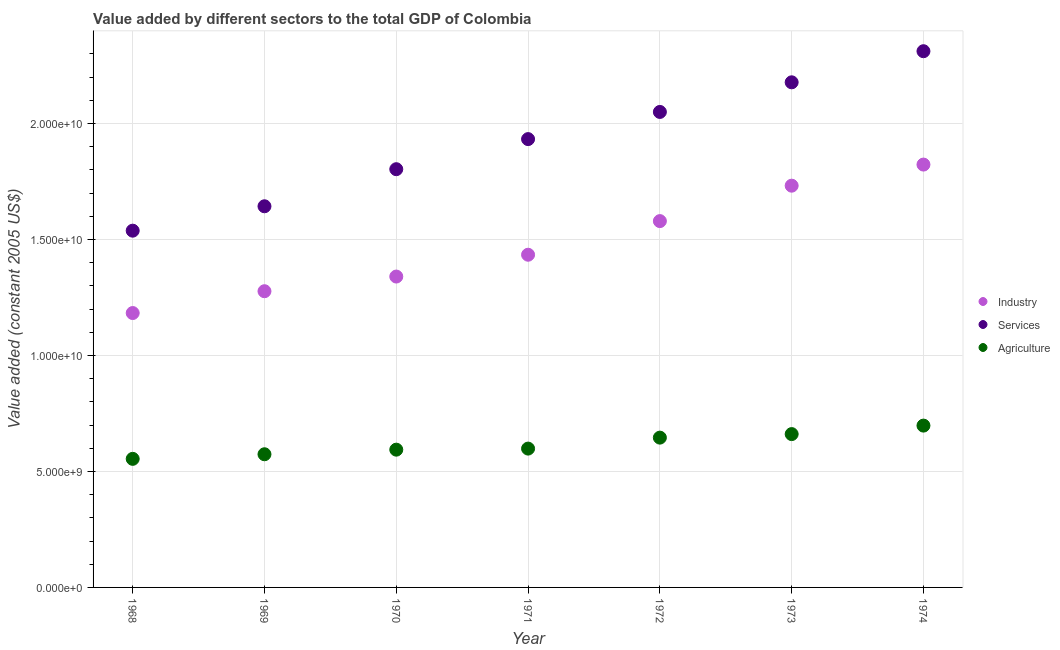How many different coloured dotlines are there?
Keep it short and to the point. 3. What is the value added by services in 1972?
Provide a short and direct response. 2.05e+1. Across all years, what is the maximum value added by industrial sector?
Make the answer very short. 1.82e+1. Across all years, what is the minimum value added by agricultural sector?
Offer a very short reply. 5.54e+09. In which year was the value added by agricultural sector maximum?
Offer a terse response. 1974. In which year was the value added by industrial sector minimum?
Make the answer very short. 1968. What is the total value added by services in the graph?
Provide a succinct answer. 1.35e+11. What is the difference between the value added by services in 1972 and that in 1974?
Ensure brevity in your answer.  -2.62e+09. What is the difference between the value added by services in 1972 and the value added by agricultural sector in 1970?
Provide a short and direct response. 1.46e+1. What is the average value added by services per year?
Your answer should be compact. 1.92e+1. In the year 1968, what is the difference between the value added by industrial sector and value added by agricultural sector?
Ensure brevity in your answer.  6.28e+09. What is the ratio of the value added by industrial sector in 1969 to that in 1971?
Make the answer very short. 0.89. What is the difference between the highest and the second highest value added by services?
Ensure brevity in your answer.  1.34e+09. What is the difference between the highest and the lowest value added by industrial sector?
Provide a succinct answer. 6.40e+09. Is the sum of the value added by agricultural sector in 1972 and 1974 greater than the maximum value added by industrial sector across all years?
Offer a terse response. No. Is it the case that in every year, the sum of the value added by industrial sector and value added by services is greater than the value added by agricultural sector?
Offer a terse response. Yes. Is the value added by services strictly less than the value added by industrial sector over the years?
Offer a terse response. No. What is the difference between two consecutive major ticks on the Y-axis?
Offer a terse response. 5.00e+09. Does the graph contain grids?
Ensure brevity in your answer.  Yes. How are the legend labels stacked?
Offer a terse response. Vertical. What is the title of the graph?
Your answer should be compact. Value added by different sectors to the total GDP of Colombia. What is the label or title of the X-axis?
Offer a terse response. Year. What is the label or title of the Y-axis?
Offer a very short reply. Value added (constant 2005 US$). What is the Value added (constant 2005 US$) in Industry in 1968?
Your answer should be very brief. 1.18e+1. What is the Value added (constant 2005 US$) of Services in 1968?
Your answer should be compact. 1.54e+1. What is the Value added (constant 2005 US$) of Agriculture in 1968?
Keep it short and to the point. 5.54e+09. What is the Value added (constant 2005 US$) in Industry in 1969?
Keep it short and to the point. 1.28e+1. What is the Value added (constant 2005 US$) in Services in 1969?
Give a very brief answer. 1.64e+1. What is the Value added (constant 2005 US$) of Agriculture in 1969?
Make the answer very short. 5.74e+09. What is the Value added (constant 2005 US$) in Industry in 1970?
Your response must be concise. 1.34e+1. What is the Value added (constant 2005 US$) of Services in 1970?
Give a very brief answer. 1.80e+1. What is the Value added (constant 2005 US$) of Agriculture in 1970?
Offer a very short reply. 5.94e+09. What is the Value added (constant 2005 US$) in Industry in 1971?
Make the answer very short. 1.43e+1. What is the Value added (constant 2005 US$) of Services in 1971?
Your answer should be compact. 1.93e+1. What is the Value added (constant 2005 US$) of Agriculture in 1971?
Provide a short and direct response. 5.98e+09. What is the Value added (constant 2005 US$) in Industry in 1972?
Offer a very short reply. 1.58e+1. What is the Value added (constant 2005 US$) in Services in 1972?
Ensure brevity in your answer.  2.05e+1. What is the Value added (constant 2005 US$) of Agriculture in 1972?
Provide a succinct answer. 6.46e+09. What is the Value added (constant 2005 US$) of Industry in 1973?
Provide a short and direct response. 1.73e+1. What is the Value added (constant 2005 US$) of Services in 1973?
Your answer should be compact. 2.18e+1. What is the Value added (constant 2005 US$) in Agriculture in 1973?
Offer a very short reply. 6.61e+09. What is the Value added (constant 2005 US$) in Industry in 1974?
Keep it short and to the point. 1.82e+1. What is the Value added (constant 2005 US$) in Services in 1974?
Your response must be concise. 2.31e+1. What is the Value added (constant 2005 US$) in Agriculture in 1974?
Offer a very short reply. 6.97e+09. Across all years, what is the maximum Value added (constant 2005 US$) in Industry?
Provide a short and direct response. 1.82e+1. Across all years, what is the maximum Value added (constant 2005 US$) of Services?
Your response must be concise. 2.31e+1. Across all years, what is the maximum Value added (constant 2005 US$) of Agriculture?
Give a very brief answer. 6.97e+09. Across all years, what is the minimum Value added (constant 2005 US$) of Industry?
Your response must be concise. 1.18e+1. Across all years, what is the minimum Value added (constant 2005 US$) in Services?
Make the answer very short. 1.54e+1. Across all years, what is the minimum Value added (constant 2005 US$) in Agriculture?
Provide a succinct answer. 5.54e+09. What is the total Value added (constant 2005 US$) in Industry in the graph?
Give a very brief answer. 1.04e+11. What is the total Value added (constant 2005 US$) of Services in the graph?
Make the answer very short. 1.35e+11. What is the total Value added (constant 2005 US$) of Agriculture in the graph?
Give a very brief answer. 4.32e+1. What is the difference between the Value added (constant 2005 US$) in Industry in 1968 and that in 1969?
Keep it short and to the point. -9.41e+08. What is the difference between the Value added (constant 2005 US$) in Services in 1968 and that in 1969?
Keep it short and to the point. -1.05e+09. What is the difference between the Value added (constant 2005 US$) of Agriculture in 1968 and that in 1969?
Your response must be concise. -1.98e+08. What is the difference between the Value added (constant 2005 US$) of Industry in 1968 and that in 1970?
Keep it short and to the point. -1.57e+09. What is the difference between the Value added (constant 2005 US$) in Services in 1968 and that in 1970?
Your answer should be compact. -2.65e+09. What is the difference between the Value added (constant 2005 US$) of Agriculture in 1968 and that in 1970?
Make the answer very short. -3.96e+08. What is the difference between the Value added (constant 2005 US$) of Industry in 1968 and that in 1971?
Offer a terse response. -2.51e+09. What is the difference between the Value added (constant 2005 US$) of Services in 1968 and that in 1971?
Your response must be concise. -3.95e+09. What is the difference between the Value added (constant 2005 US$) in Agriculture in 1968 and that in 1971?
Make the answer very short. -4.42e+08. What is the difference between the Value added (constant 2005 US$) in Industry in 1968 and that in 1972?
Keep it short and to the point. -3.96e+09. What is the difference between the Value added (constant 2005 US$) in Services in 1968 and that in 1972?
Make the answer very short. -5.12e+09. What is the difference between the Value added (constant 2005 US$) of Agriculture in 1968 and that in 1972?
Offer a terse response. -9.15e+08. What is the difference between the Value added (constant 2005 US$) of Industry in 1968 and that in 1973?
Your response must be concise. -5.49e+09. What is the difference between the Value added (constant 2005 US$) of Services in 1968 and that in 1973?
Give a very brief answer. -6.40e+09. What is the difference between the Value added (constant 2005 US$) in Agriculture in 1968 and that in 1973?
Provide a short and direct response. -1.07e+09. What is the difference between the Value added (constant 2005 US$) in Industry in 1968 and that in 1974?
Provide a short and direct response. -6.40e+09. What is the difference between the Value added (constant 2005 US$) in Services in 1968 and that in 1974?
Provide a succinct answer. -7.74e+09. What is the difference between the Value added (constant 2005 US$) in Agriculture in 1968 and that in 1974?
Make the answer very short. -1.43e+09. What is the difference between the Value added (constant 2005 US$) of Industry in 1969 and that in 1970?
Your answer should be very brief. -6.32e+08. What is the difference between the Value added (constant 2005 US$) in Services in 1969 and that in 1970?
Provide a succinct answer. -1.60e+09. What is the difference between the Value added (constant 2005 US$) of Agriculture in 1969 and that in 1970?
Offer a terse response. -1.98e+08. What is the difference between the Value added (constant 2005 US$) in Industry in 1969 and that in 1971?
Keep it short and to the point. -1.57e+09. What is the difference between the Value added (constant 2005 US$) in Services in 1969 and that in 1971?
Your answer should be compact. -2.90e+09. What is the difference between the Value added (constant 2005 US$) in Agriculture in 1969 and that in 1971?
Your answer should be compact. -2.44e+08. What is the difference between the Value added (constant 2005 US$) in Industry in 1969 and that in 1972?
Make the answer very short. -3.02e+09. What is the difference between the Value added (constant 2005 US$) in Services in 1969 and that in 1972?
Provide a succinct answer. -4.07e+09. What is the difference between the Value added (constant 2005 US$) in Agriculture in 1969 and that in 1972?
Offer a terse response. -7.17e+08. What is the difference between the Value added (constant 2005 US$) of Industry in 1969 and that in 1973?
Your answer should be very brief. -4.55e+09. What is the difference between the Value added (constant 2005 US$) in Services in 1969 and that in 1973?
Ensure brevity in your answer.  -5.34e+09. What is the difference between the Value added (constant 2005 US$) in Agriculture in 1969 and that in 1973?
Ensure brevity in your answer.  -8.69e+08. What is the difference between the Value added (constant 2005 US$) in Industry in 1969 and that in 1974?
Your answer should be compact. -5.46e+09. What is the difference between the Value added (constant 2005 US$) of Services in 1969 and that in 1974?
Your answer should be very brief. -6.68e+09. What is the difference between the Value added (constant 2005 US$) in Agriculture in 1969 and that in 1974?
Your answer should be compact. -1.23e+09. What is the difference between the Value added (constant 2005 US$) in Industry in 1970 and that in 1971?
Keep it short and to the point. -9.41e+08. What is the difference between the Value added (constant 2005 US$) in Services in 1970 and that in 1971?
Provide a succinct answer. -1.30e+09. What is the difference between the Value added (constant 2005 US$) in Agriculture in 1970 and that in 1971?
Offer a very short reply. -4.57e+07. What is the difference between the Value added (constant 2005 US$) of Industry in 1970 and that in 1972?
Give a very brief answer. -2.39e+09. What is the difference between the Value added (constant 2005 US$) in Services in 1970 and that in 1972?
Your response must be concise. -2.47e+09. What is the difference between the Value added (constant 2005 US$) in Agriculture in 1970 and that in 1972?
Ensure brevity in your answer.  -5.18e+08. What is the difference between the Value added (constant 2005 US$) in Industry in 1970 and that in 1973?
Provide a succinct answer. -3.92e+09. What is the difference between the Value added (constant 2005 US$) of Services in 1970 and that in 1973?
Your response must be concise. -3.75e+09. What is the difference between the Value added (constant 2005 US$) of Agriculture in 1970 and that in 1973?
Provide a short and direct response. -6.71e+08. What is the difference between the Value added (constant 2005 US$) of Industry in 1970 and that in 1974?
Make the answer very short. -4.83e+09. What is the difference between the Value added (constant 2005 US$) of Services in 1970 and that in 1974?
Keep it short and to the point. -5.09e+09. What is the difference between the Value added (constant 2005 US$) of Agriculture in 1970 and that in 1974?
Offer a very short reply. -1.04e+09. What is the difference between the Value added (constant 2005 US$) in Industry in 1971 and that in 1972?
Keep it short and to the point. -1.45e+09. What is the difference between the Value added (constant 2005 US$) in Services in 1971 and that in 1972?
Your response must be concise. -1.17e+09. What is the difference between the Value added (constant 2005 US$) in Agriculture in 1971 and that in 1972?
Your answer should be compact. -4.73e+08. What is the difference between the Value added (constant 2005 US$) in Industry in 1971 and that in 1973?
Offer a terse response. -2.98e+09. What is the difference between the Value added (constant 2005 US$) of Services in 1971 and that in 1973?
Your response must be concise. -2.45e+09. What is the difference between the Value added (constant 2005 US$) in Agriculture in 1971 and that in 1973?
Give a very brief answer. -6.25e+08. What is the difference between the Value added (constant 2005 US$) of Industry in 1971 and that in 1974?
Offer a terse response. -3.89e+09. What is the difference between the Value added (constant 2005 US$) of Services in 1971 and that in 1974?
Give a very brief answer. -3.79e+09. What is the difference between the Value added (constant 2005 US$) in Agriculture in 1971 and that in 1974?
Your answer should be compact. -9.91e+08. What is the difference between the Value added (constant 2005 US$) in Industry in 1972 and that in 1973?
Make the answer very short. -1.53e+09. What is the difference between the Value added (constant 2005 US$) in Services in 1972 and that in 1973?
Your response must be concise. -1.28e+09. What is the difference between the Value added (constant 2005 US$) in Agriculture in 1972 and that in 1973?
Provide a succinct answer. -1.52e+08. What is the difference between the Value added (constant 2005 US$) of Industry in 1972 and that in 1974?
Give a very brief answer. -2.44e+09. What is the difference between the Value added (constant 2005 US$) in Services in 1972 and that in 1974?
Give a very brief answer. -2.62e+09. What is the difference between the Value added (constant 2005 US$) of Agriculture in 1972 and that in 1974?
Ensure brevity in your answer.  -5.18e+08. What is the difference between the Value added (constant 2005 US$) of Industry in 1973 and that in 1974?
Ensure brevity in your answer.  -9.10e+08. What is the difference between the Value added (constant 2005 US$) of Services in 1973 and that in 1974?
Offer a very short reply. -1.34e+09. What is the difference between the Value added (constant 2005 US$) in Agriculture in 1973 and that in 1974?
Offer a very short reply. -3.66e+08. What is the difference between the Value added (constant 2005 US$) in Industry in 1968 and the Value added (constant 2005 US$) in Services in 1969?
Offer a terse response. -4.60e+09. What is the difference between the Value added (constant 2005 US$) in Industry in 1968 and the Value added (constant 2005 US$) in Agriculture in 1969?
Make the answer very short. 6.09e+09. What is the difference between the Value added (constant 2005 US$) of Services in 1968 and the Value added (constant 2005 US$) of Agriculture in 1969?
Ensure brevity in your answer.  9.64e+09. What is the difference between the Value added (constant 2005 US$) in Industry in 1968 and the Value added (constant 2005 US$) in Services in 1970?
Your response must be concise. -6.20e+09. What is the difference between the Value added (constant 2005 US$) of Industry in 1968 and the Value added (constant 2005 US$) of Agriculture in 1970?
Ensure brevity in your answer.  5.89e+09. What is the difference between the Value added (constant 2005 US$) of Services in 1968 and the Value added (constant 2005 US$) of Agriculture in 1970?
Give a very brief answer. 9.44e+09. What is the difference between the Value added (constant 2005 US$) in Industry in 1968 and the Value added (constant 2005 US$) in Services in 1971?
Provide a short and direct response. -7.50e+09. What is the difference between the Value added (constant 2005 US$) in Industry in 1968 and the Value added (constant 2005 US$) in Agriculture in 1971?
Your response must be concise. 5.84e+09. What is the difference between the Value added (constant 2005 US$) in Services in 1968 and the Value added (constant 2005 US$) in Agriculture in 1971?
Offer a very short reply. 9.39e+09. What is the difference between the Value added (constant 2005 US$) of Industry in 1968 and the Value added (constant 2005 US$) of Services in 1972?
Ensure brevity in your answer.  -8.67e+09. What is the difference between the Value added (constant 2005 US$) of Industry in 1968 and the Value added (constant 2005 US$) of Agriculture in 1972?
Ensure brevity in your answer.  5.37e+09. What is the difference between the Value added (constant 2005 US$) in Services in 1968 and the Value added (constant 2005 US$) in Agriculture in 1972?
Offer a very short reply. 8.92e+09. What is the difference between the Value added (constant 2005 US$) in Industry in 1968 and the Value added (constant 2005 US$) in Services in 1973?
Your answer should be very brief. -9.95e+09. What is the difference between the Value added (constant 2005 US$) of Industry in 1968 and the Value added (constant 2005 US$) of Agriculture in 1973?
Provide a succinct answer. 5.22e+09. What is the difference between the Value added (constant 2005 US$) of Services in 1968 and the Value added (constant 2005 US$) of Agriculture in 1973?
Your answer should be very brief. 8.77e+09. What is the difference between the Value added (constant 2005 US$) in Industry in 1968 and the Value added (constant 2005 US$) in Services in 1974?
Offer a very short reply. -1.13e+1. What is the difference between the Value added (constant 2005 US$) of Industry in 1968 and the Value added (constant 2005 US$) of Agriculture in 1974?
Your answer should be very brief. 4.85e+09. What is the difference between the Value added (constant 2005 US$) of Services in 1968 and the Value added (constant 2005 US$) of Agriculture in 1974?
Your answer should be very brief. 8.40e+09. What is the difference between the Value added (constant 2005 US$) in Industry in 1969 and the Value added (constant 2005 US$) in Services in 1970?
Ensure brevity in your answer.  -5.26e+09. What is the difference between the Value added (constant 2005 US$) of Industry in 1969 and the Value added (constant 2005 US$) of Agriculture in 1970?
Your response must be concise. 6.83e+09. What is the difference between the Value added (constant 2005 US$) of Services in 1969 and the Value added (constant 2005 US$) of Agriculture in 1970?
Offer a terse response. 1.05e+1. What is the difference between the Value added (constant 2005 US$) in Industry in 1969 and the Value added (constant 2005 US$) in Services in 1971?
Your response must be concise. -6.56e+09. What is the difference between the Value added (constant 2005 US$) of Industry in 1969 and the Value added (constant 2005 US$) of Agriculture in 1971?
Provide a succinct answer. 6.78e+09. What is the difference between the Value added (constant 2005 US$) in Services in 1969 and the Value added (constant 2005 US$) in Agriculture in 1971?
Your answer should be very brief. 1.04e+1. What is the difference between the Value added (constant 2005 US$) of Industry in 1969 and the Value added (constant 2005 US$) of Services in 1972?
Make the answer very short. -7.73e+09. What is the difference between the Value added (constant 2005 US$) of Industry in 1969 and the Value added (constant 2005 US$) of Agriculture in 1972?
Provide a succinct answer. 6.31e+09. What is the difference between the Value added (constant 2005 US$) in Services in 1969 and the Value added (constant 2005 US$) in Agriculture in 1972?
Provide a short and direct response. 9.97e+09. What is the difference between the Value added (constant 2005 US$) in Industry in 1969 and the Value added (constant 2005 US$) in Services in 1973?
Give a very brief answer. -9.00e+09. What is the difference between the Value added (constant 2005 US$) of Industry in 1969 and the Value added (constant 2005 US$) of Agriculture in 1973?
Offer a very short reply. 6.16e+09. What is the difference between the Value added (constant 2005 US$) of Services in 1969 and the Value added (constant 2005 US$) of Agriculture in 1973?
Offer a terse response. 9.82e+09. What is the difference between the Value added (constant 2005 US$) in Industry in 1969 and the Value added (constant 2005 US$) in Services in 1974?
Ensure brevity in your answer.  -1.03e+1. What is the difference between the Value added (constant 2005 US$) of Industry in 1969 and the Value added (constant 2005 US$) of Agriculture in 1974?
Offer a very short reply. 5.79e+09. What is the difference between the Value added (constant 2005 US$) of Services in 1969 and the Value added (constant 2005 US$) of Agriculture in 1974?
Provide a short and direct response. 9.45e+09. What is the difference between the Value added (constant 2005 US$) of Industry in 1970 and the Value added (constant 2005 US$) of Services in 1971?
Give a very brief answer. -5.92e+09. What is the difference between the Value added (constant 2005 US$) in Industry in 1970 and the Value added (constant 2005 US$) in Agriculture in 1971?
Your response must be concise. 7.42e+09. What is the difference between the Value added (constant 2005 US$) in Services in 1970 and the Value added (constant 2005 US$) in Agriculture in 1971?
Give a very brief answer. 1.20e+1. What is the difference between the Value added (constant 2005 US$) of Industry in 1970 and the Value added (constant 2005 US$) of Services in 1972?
Provide a succinct answer. -7.10e+09. What is the difference between the Value added (constant 2005 US$) in Industry in 1970 and the Value added (constant 2005 US$) in Agriculture in 1972?
Make the answer very short. 6.94e+09. What is the difference between the Value added (constant 2005 US$) of Services in 1970 and the Value added (constant 2005 US$) of Agriculture in 1972?
Offer a very short reply. 1.16e+1. What is the difference between the Value added (constant 2005 US$) of Industry in 1970 and the Value added (constant 2005 US$) of Services in 1973?
Make the answer very short. -8.37e+09. What is the difference between the Value added (constant 2005 US$) in Industry in 1970 and the Value added (constant 2005 US$) in Agriculture in 1973?
Ensure brevity in your answer.  6.79e+09. What is the difference between the Value added (constant 2005 US$) of Services in 1970 and the Value added (constant 2005 US$) of Agriculture in 1973?
Make the answer very short. 1.14e+1. What is the difference between the Value added (constant 2005 US$) in Industry in 1970 and the Value added (constant 2005 US$) in Services in 1974?
Provide a short and direct response. -9.71e+09. What is the difference between the Value added (constant 2005 US$) of Industry in 1970 and the Value added (constant 2005 US$) of Agriculture in 1974?
Make the answer very short. 6.42e+09. What is the difference between the Value added (constant 2005 US$) in Services in 1970 and the Value added (constant 2005 US$) in Agriculture in 1974?
Offer a terse response. 1.11e+1. What is the difference between the Value added (constant 2005 US$) in Industry in 1971 and the Value added (constant 2005 US$) in Services in 1972?
Keep it short and to the point. -6.15e+09. What is the difference between the Value added (constant 2005 US$) of Industry in 1971 and the Value added (constant 2005 US$) of Agriculture in 1972?
Give a very brief answer. 7.88e+09. What is the difference between the Value added (constant 2005 US$) in Services in 1971 and the Value added (constant 2005 US$) in Agriculture in 1972?
Your response must be concise. 1.29e+1. What is the difference between the Value added (constant 2005 US$) in Industry in 1971 and the Value added (constant 2005 US$) in Services in 1973?
Provide a short and direct response. -7.43e+09. What is the difference between the Value added (constant 2005 US$) of Industry in 1971 and the Value added (constant 2005 US$) of Agriculture in 1973?
Make the answer very short. 7.73e+09. What is the difference between the Value added (constant 2005 US$) of Services in 1971 and the Value added (constant 2005 US$) of Agriculture in 1973?
Give a very brief answer. 1.27e+1. What is the difference between the Value added (constant 2005 US$) in Industry in 1971 and the Value added (constant 2005 US$) in Services in 1974?
Give a very brief answer. -8.77e+09. What is the difference between the Value added (constant 2005 US$) in Industry in 1971 and the Value added (constant 2005 US$) in Agriculture in 1974?
Ensure brevity in your answer.  7.37e+09. What is the difference between the Value added (constant 2005 US$) of Services in 1971 and the Value added (constant 2005 US$) of Agriculture in 1974?
Make the answer very short. 1.23e+1. What is the difference between the Value added (constant 2005 US$) in Industry in 1972 and the Value added (constant 2005 US$) in Services in 1973?
Provide a short and direct response. -5.98e+09. What is the difference between the Value added (constant 2005 US$) of Industry in 1972 and the Value added (constant 2005 US$) of Agriculture in 1973?
Offer a very short reply. 9.18e+09. What is the difference between the Value added (constant 2005 US$) in Services in 1972 and the Value added (constant 2005 US$) in Agriculture in 1973?
Your response must be concise. 1.39e+1. What is the difference between the Value added (constant 2005 US$) of Industry in 1972 and the Value added (constant 2005 US$) of Services in 1974?
Your response must be concise. -7.32e+09. What is the difference between the Value added (constant 2005 US$) in Industry in 1972 and the Value added (constant 2005 US$) in Agriculture in 1974?
Provide a succinct answer. 8.81e+09. What is the difference between the Value added (constant 2005 US$) of Services in 1972 and the Value added (constant 2005 US$) of Agriculture in 1974?
Make the answer very short. 1.35e+1. What is the difference between the Value added (constant 2005 US$) of Industry in 1973 and the Value added (constant 2005 US$) of Services in 1974?
Your answer should be very brief. -5.80e+09. What is the difference between the Value added (constant 2005 US$) of Industry in 1973 and the Value added (constant 2005 US$) of Agriculture in 1974?
Ensure brevity in your answer.  1.03e+1. What is the difference between the Value added (constant 2005 US$) in Services in 1973 and the Value added (constant 2005 US$) in Agriculture in 1974?
Make the answer very short. 1.48e+1. What is the average Value added (constant 2005 US$) of Industry per year?
Your answer should be very brief. 1.48e+1. What is the average Value added (constant 2005 US$) of Services per year?
Ensure brevity in your answer.  1.92e+1. What is the average Value added (constant 2005 US$) of Agriculture per year?
Offer a very short reply. 6.18e+09. In the year 1968, what is the difference between the Value added (constant 2005 US$) of Industry and Value added (constant 2005 US$) of Services?
Give a very brief answer. -3.55e+09. In the year 1968, what is the difference between the Value added (constant 2005 US$) of Industry and Value added (constant 2005 US$) of Agriculture?
Give a very brief answer. 6.28e+09. In the year 1968, what is the difference between the Value added (constant 2005 US$) of Services and Value added (constant 2005 US$) of Agriculture?
Give a very brief answer. 9.84e+09. In the year 1969, what is the difference between the Value added (constant 2005 US$) of Industry and Value added (constant 2005 US$) of Services?
Offer a terse response. -3.66e+09. In the year 1969, what is the difference between the Value added (constant 2005 US$) of Industry and Value added (constant 2005 US$) of Agriculture?
Ensure brevity in your answer.  7.03e+09. In the year 1969, what is the difference between the Value added (constant 2005 US$) in Services and Value added (constant 2005 US$) in Agriculture?
Make the answer very short. 1.07e+1. In the year 1970, what is the difference between the Value added (constant 2005 US$) in Industry and Value added (constant 2005 US$) in Services?
Provide a succinct answer. -4.63e+09. In the year 1970, what is the difference between the Value added (constant 2005 US$) in Industry and Value added (constant 2005 US$) in Agriculture?
Give a very brief answer. 7.46e+09. In the year 1970, what is the difference between the Value added (constant 2005 US$) of Services and Value added (constant 2005 US$) of Agriculture?
Provide a succinct answer. 1.21e+1. In the year 1971, what is the difference between the Value added (constant 2005 US$) of Industry and Value added (constant 2005 US$) of Services?
Keep it short and to the point. -4.98e+09. In the year 1971, what is the difference between the Value added (constant 2005 US$) of Industry and Value added (constant 2005 US$) of Agriculture?
Keep it short and to the point. 8.36e+09. In the year 1971, what is the difference between the Value added (constant 2005 US$) in Services and Value added (constant 2005 US$) in Agriculture?
Your answer should be compact. 1.33e+1. In the year 1972, what is the difference between the Value added (constant 2005 US$) in Industry and Value added (constant 2005 US$) in Services?
Your answer should be very brief. -4.71e+09. In the year 1972, what is the difference between the Value added (constant 2005 US$) of Industry and Value added (constant 2005 US$) of Agriculture?
Keep it short and to the point. 9.33e+09. In the year 1972, what is the difference between the Value added (constant 2005 US$) of Services and Value added (constant 2005 US$) of Agriculture?
Offer a terse response. 1.40e+1. In the year 1973, what is the difference between the Value added (constant 2005 US$) of Industry and Value added (constant 2005 US$) of Services?
Ensure brevity in your answer.  -4.46e+09. In the year 1973, what is the difference between the Value added (constant 2005 US$) of Industry and Value added (constant 2005 US$) of Agriculture?
Offer a very short reply. 1.07e+1. In the year 1973, what is the difference between the Value added (constant 2005 US$) in Services and Value added (constant 2005 US$) in Agriculture?
Your answer should be compact. 1.52e+1. In the year 1974, what is the difference between the Value added (constant 2005 US$) of Industry and Value added (constant 2005 US$) of Services?
Make the answer very short. -4.89e+09. In the year 1974, what is the difference between the Value added (constant 2005 US$) in Industry and Value added (constant 2005 US$) in Agriculture?
Your answer should be very brief. 1.13e+1. In the year 1974, what is the difference between the Value added (constant 2005 US$) in Services and Value added (constant 2005 US$) in Agriculture?
Ensure brevity in your answer.  1.61e+1. What is the ratio of the Value added (constant 2005 US$) of Industry in 1968 to that in 1969?
Your answer should be compact. 0.93. What is the ratio of the Value added (constant 2005 US$) of Services in 1968 to that in 1969?
Ensure brevity in your answer.  0.94. What is the ratio of the Value added (constant 2005 US$) of Agriculture in 1968 to that in 1969?
Your response must be concise. 0.97. What is the ratio of the Value added (constant 2005 US$) of Industry in 1968 to that in 1970?
Your answer should be compact. 0.88. What is the ratio of the Value added (constant 2005 US$) in Services in 1968 to that in 1970?
Offer a very short reply. 0.85. What is the ratio of the Value added (constant 2005 US$) in Agriculture in 1968 to that in 1970?
Offer a very short reply. 0.93. What is the ratio of the Value added (constant 2005 US$) of Industry in 1968 to that in 1971?
Keep it short and to the point. 0.82. What is the ratio of the Value added (constant 2005 US$) in Services in 1968 to that in 1971?
Offer a terse response. 0.8. What is the ratio of the Value added (constant 2005 US$) of Agriculture in 1968 to that in 1971?
Your answer should be very brief. 0.93. What is the ratio of the Value added (constant 2005 US$) of Industry in 1968 to that in 1972?
Give a very brief answer. 0.75. What is the ratio of the Value added (constant 2005 US$) in Services in 1968 to that in 1972?
Offer a very short reply. 0.75. What is the ratio of the Value added (constant 2005 US$) of Agriculture in 1968 to that in 1972?
Give a very brief answer. 0.86. What is the ratio of the Value added (constant 2005 US$) of Industry in 1968 to that in 1973?
Ensure brevity in your answer.  0.68. What is the ratio of the Value added (constant 2005 US$) in Services in 1968 to that in 1973?
Provide a short and direct response. 0.71. What is the ratio of the Value added (constant 2005 US$) in Agriculture in 1968 to that in 1973?
Make the answer very short. 0.84. What is the ratio of the Value added (constant 2005 US$) in Industry in 1968 to that in 1974?
Your answer should be very brief. 0.65. What is the ratio of the Value added (constant 2005 US$) in Services in 1968 to that in 1974?
Offer a very short reply. 0.67. What is the ratio of the Value added (constant 2005 US$) of Agriculture in 1968 to that in 1974?
Offer a very short reply. 0.79. What is the ratio of the Value added (constant 2005 US$) in Industry in 1969 to that in 1970?
Provide a succinct answer. 0.95. What is the ratio of the Value added (constant 2005 US$) of Services in 1969 to that in 1970?
Offer a very short reply. 0.91. What is the ratio of the Value added (constant 2005 US$) in Agriculture in 1969 to that in 1970?
Provide a succinct answer. 0.97. What is the ratio of the Value added (constant 2005 US$) of Industry in 1969 to that in 1971?
Ensure brevity in your answer.  0.89. What is the ratio of the Value added (constant 2005 US$) of Services in 1969 to that in 1971?
Offer a very short reply. 0.85. What is the ratio of the Value added (constant 2005 US$) of Agriculture in 1969 to that in 1971?
Give a very brief answer. 0.96. What is the ratio of the Value added (constant 2005 US$) of Industry in 1969 to that in 1972?
Make the answer very short. 0.81. What is the ratio of the Value added (constant 2005 US$) in Services in 1969 to that in 1972?
Your answer should be compact. 0.8. What is the ratio of the Value added (constant 2005 US$) in Agriculture in 1969 to that in 1972?
Your answer should be compact. 0.89. What is the ratio of the Value added (constant 2005 US$) of Industry in 1969 to that in 1973?
Keep it short and to the point. 0.74. What is the ratio of the Value added (constant 2005 US$) in Services in 1969 to that in 1973?
Your answer should be compact. 0.75. What is the ratio of the Value added (constant 2005 US$) in Agriculture in 1969 to that in 1973?
Make the answer very short. 0.87. What is the ratio of the Value added (constant 2005 US$) in Industry in 1969 to that in 1974?
Make the answer very short. 0.7. What is the ratio of the Value added (constant 2005 US$) in Services in 1969 to that in 1974?
Provide a succinct answer. 0.71. What is the ratio of the Value added (constant 2005 US$) in Agriculture in 1969 to that in 1974?
Offer a very short reply. 0.82. What is the ratio of the Value added (constant 2005 US$) of Industry in 1970 to that in 1971?
Keep it short and to the point. 0.93. What is the ratio of the Value added (constant 2005 US$) in Services in 1970 to that in 1971?
Ensure brevity in your answer.  0.93. What is the ratio of the Value added (constant 2005 US$) in Industry in 1970 to that in 1972?
Your answer should be very brief. 0.85. What is the ratio of the Value added (constant 2005 US$) in Services in 1970 to that in 1972?
Provide a succinct answer. 0.88. What is the ratio of the Value added (constant 2005 US$) of Agriculture in 1970 to that in 1972?
Offer a terse response. 0.92. What is the ratio of the Value added (constant 2005 US$) of Industry in 1970 to that in 1973?
Make the answer very short. 0.77. What is the ratio of the Value added (constant 2005 US$) in Services in 1970 to that in 1973?
Keep it short and to the point. 0.83. What is the ratio of the Value added (constant 2005 US$) in Agriculture in 1970 to that in 1973?
Your response must be concise. 0.9. What is the ratio of the Value added (constant 2005 US$) in Industry in 1970 to that in 1974?
Your response must be concise. 0.74. What is the ratio of the Value added (constant 2005 US$) of Services in 1970 to that in 1974?
Keep it short and to the point. 0.78. What is the ratio of the Value added (constant 2005 US$) of Agriculture in 1970 to that in 1974?
Give a very brief answer. 0.85. What is the ratio of the Value added (constant 2005 US$) in Industry in 1971 to that in 1972?
Give a very brief answer. 0.91. What is the ratio of the Value added (constant 2005 US$) in Services in 1971 to that in 1972?
Keep it short and to the point. 0.94. What is the ratio of the Value added (constant 2005 US$) of Agriculture in 1971 to that in 1972?
Your response must be concise. 0.93. What is the ratio of the Value added (constant 2005 US$) in Industry in 1971 to that in 1973?
Provide a succinct answer. 0.83. What is the ratio of the Value added (constant 2005 US$) in Services in 1971 to that in 1973?
Make the answer very short. 0.89. What is the ratio of the Value added (constant 2005 US$) of Agriculture in 1971 to that in 1973?
Make the answer very short. 0.91. What is the ratio of the Value added (constant 2005 US$) of Industry in 1971 to that in 1974?
Ensure brevity in your answer.  0.79. What is the ratio of the Value added (constant 2005 US$) in Services in 1971 to that in 1974?
Make the answer very short. 0.84. What is the ratio of the Value added (constant 2005 US$) of Agriculture in 1971 to that in 1974?
Give a very brief answer. 0.86. What is the ratio of the Value added (constant 2005 US$) in Industry in 1972 to that in 1973?
Your answer should be compact. 0.91. What is the ratio of the Value added (constant 2005 US$) in Services in 1972 to that in 1973?
Make the answer very short. 0.94. What is the ratio of the Value added (constant 2005 US$) of Agriculture in 1972 to that in 1973?
Provide a succinct answer. 0.98. What is the ratio of the Value added (constant 2005 US$) in Industry in 1972 to that in 1974?
Provide a succinct answer. 0.87. What is the ratio of the Value added (constant 2005 US$) in Services in 1972 to that in 1974?
Your answer should be compact. 0.89. What is the ratio of the Value added (constant 2005 US$) in Agriculture in 1972 to that in 1974?
Your answer should be compact. 0.93. What is the ratio of the Value added (constant 2005 US$) of Industry in 1973 to that in 1974?
Your response must be concise. 0.95. What is the ratio of the Value added (constant 2005 US$) of Services in 1973 to that in 1974?
Your response must be concise. 0.94. What is the ratio of the Value added (constant 2005 US$) in Agriculture in 1973 to that in 1974?
Provide a short and direct response. 0.95. What is the difference between the highest and the second highest Value added (constant 2005 US$) of Industry?
Your answer should be compact. 9.10e+08. What is the difference between the highest and the second highest Value added (constant 2005 US$) in Services?
Your response must be concise. 1.34e+09. What is the difference between the highest and the second highest Value added (constant 2005 US$) of Agriculture?
Your response must be concise. 3.66e+08. What is the difference between the highest and the lowest Value added (constant 2005 US$) of Industry?
Ensure brevity in your answer.  6.40e+09. What is the difference between the highest and the lowest Value added (constant 2005 US$) of Services?
Your answer should be compact. 7.74e+09. What is the difference between the highest and the lowest Value added (constant 2005 US$) in Agriculture?
Make the answer very short. 1.43e+09. 